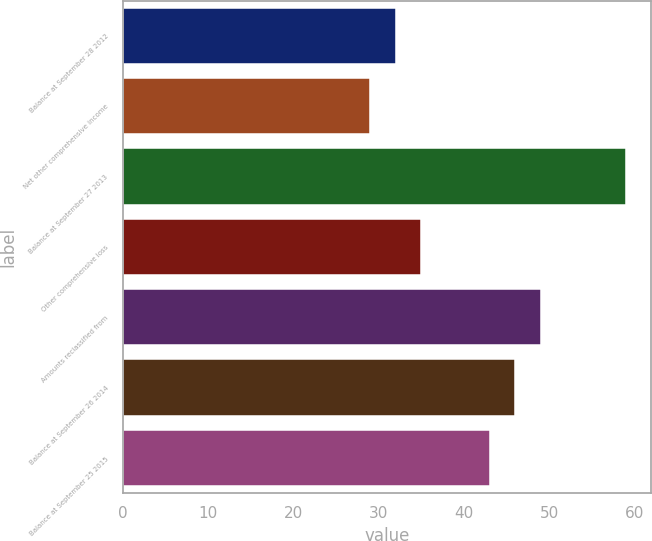Convert chart to OTSL. <chart><loc_0><loc_0><loc_500><loc_500><bar_chart><fcel>Balance at September 28 2012<fcel>Net other comprehensive income<fcel>Balance at September 27 2013<fcel>Other comprehensive loss<fcel>Amounts reclassified from<fcel>Balance at September 26 2014<fcel>Balance at September 25 2015<nl><fcel>32<fcel>29<fcel>59<fcel>35<fcel>49<fcel>46<fcel>43<nl></chart> 